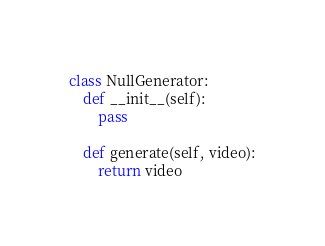Convert code to text. <code><loc_0><loc_0><loc_500><loc_500><_Python_>class NullGenerator:
    def __init__(self):
        pass

    def generate(self, video):
        return video
</code> 